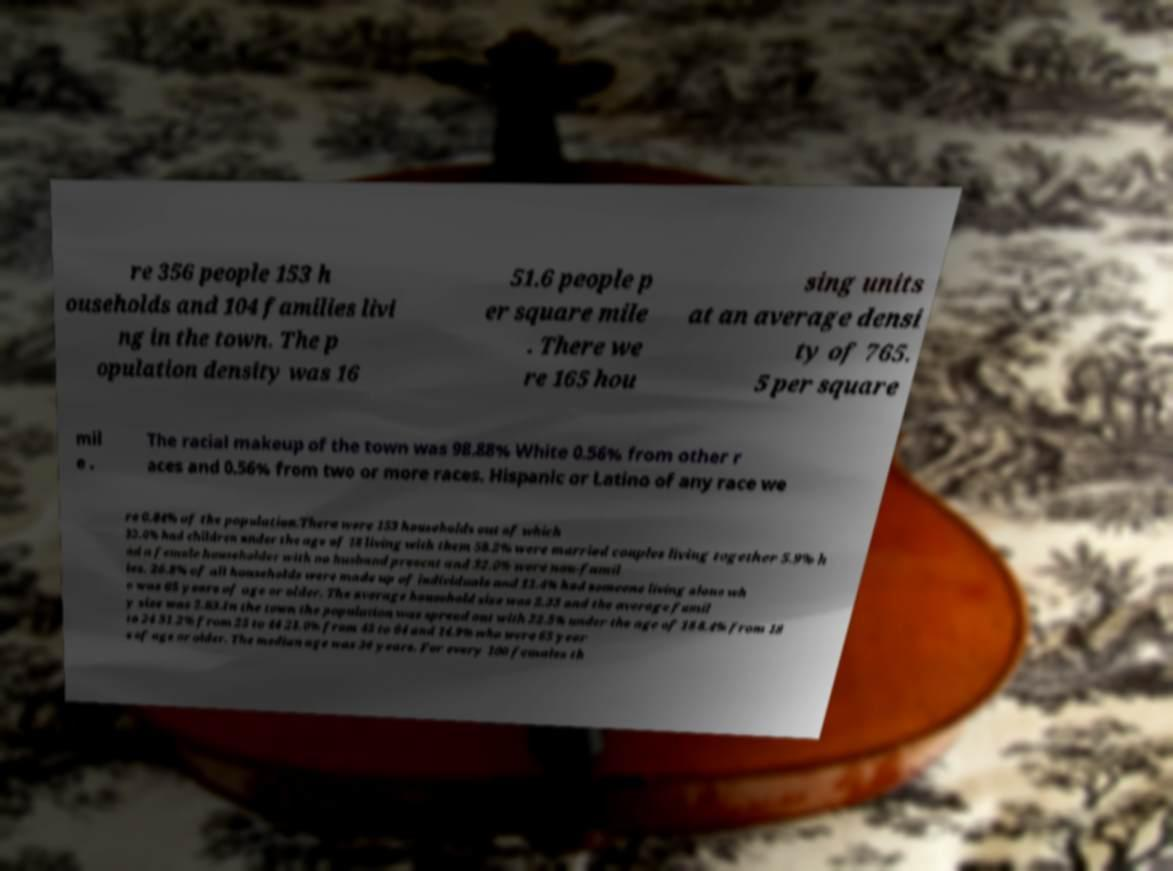There's text embedded in this image that I need extracted. Can you transcribe it verbatim? re 356 people 153 h ouseholds and 104 families livi ng in the town. The p opulation density was 16 51.6 people p er square mile . There we re 165 hou sing units at an average densi ty of 765. 5 per square mil e . The racial makeup of the town was 98.88% White 0.56% from other r aces and 0.56% from two or more races. Hispanic or Latino of any race we re 0.84% of the population.There were 153 households out of which 32.0% had children under the age of 18 living with them 58.2% were married couples living together 5.9% h ad a female householder with no husband present and 32.0% were non-famil ies. 26.8% of all households were made up of individuals and 12.4% had someone living alone wh o was 65 years of age or older. The average household size was 2.33 and the average famil y size was 2.83.In the town the population was spread out with 22.5% under the age of 18 8.4% from 18 to 24 31.2% from 25 to 44 23.0% from 45 to 64 and 14.9% who were 65 year s of age or older. The median age was 36 years. For every 100 females th 